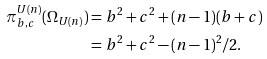<formula> <loc_0><loc_0><loc_500><loc_500>\pi ^ { U ( n ) } _ { b , c } ( \Omega _ { U ( n ) } ) & = b ^ { 2 } + c ^ { 2 } + ( n - 1 ) ( b + c ) \\ & = b ^ { 2 } + c ^ { 2 } - ( n - 1 ) ^ { 2 } / 2 .</formula> 